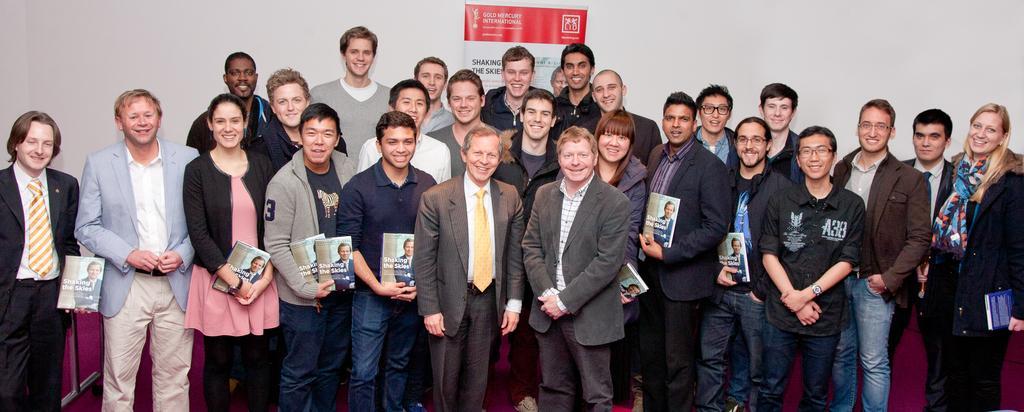How would you summarize this image in a sentence or two? In this picture I can see there is a group of people standing and there are men and women standing, few people are holding books, there is a wall in the backdrop and there is a banner on it. The men are wearing blazers and all of them are smiling. 